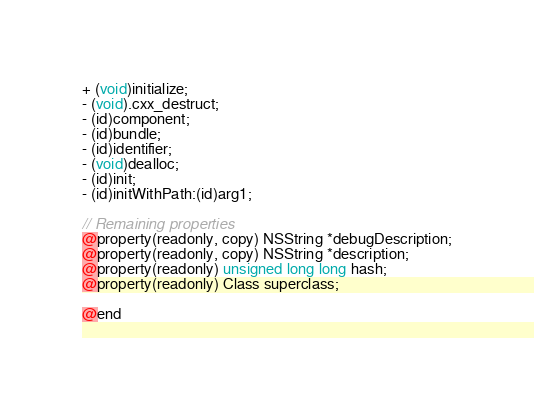<code> <loc_0><loc_0><loc_500><loc_500><_C_>+ (void)initialize;
- (void).cxx_destruct;
- (id)component;
- (id)bundle;
- (id)identifier;
- (void)dealloc;
- (id)init;
- (id)initWithPath:(id)arg1;

// Remaining properties
@property(readonly, copy) NSString *debugDescription;
@property(readonly, copy) NSString *description;
@property(readonly) unsigned long long hash;
@property(readonly) Class superclass;

@end

</code> 